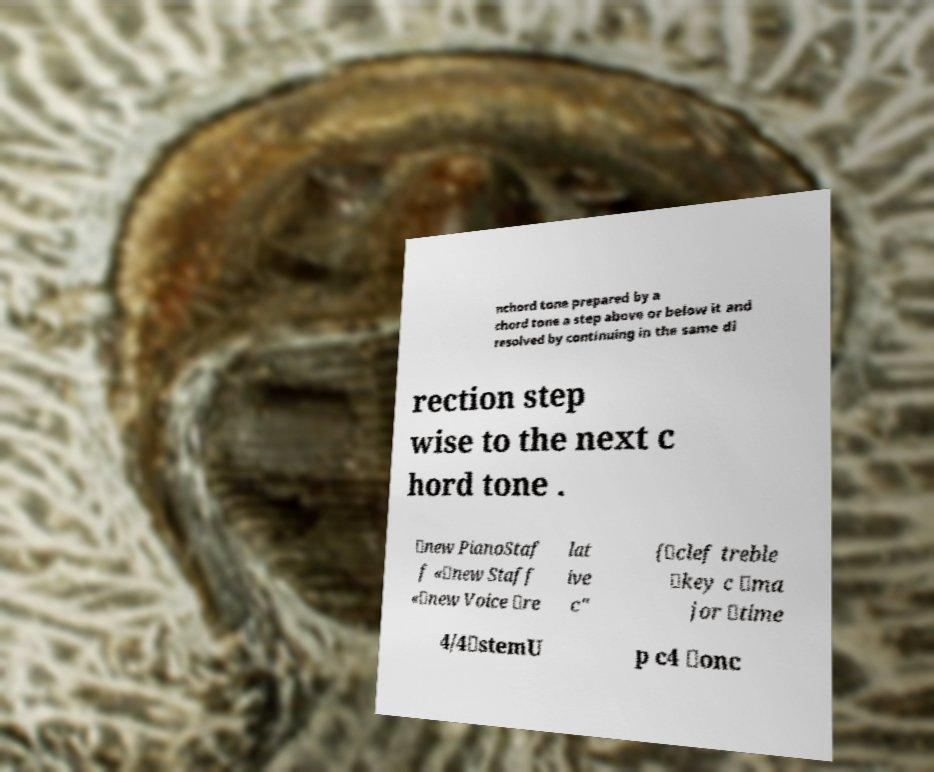Please read and relay the text visible in this image. What does it say? nchord tone prepared by a chord tone a step above or below it and resolved by continuing in the same di rection step wise to the next c hord tone . \new PianoStaf f «\new Staff «\new Voice \re lat ive c" {\clef treble \key c \ma jor \time 4/4\stemU p c4 \onc 